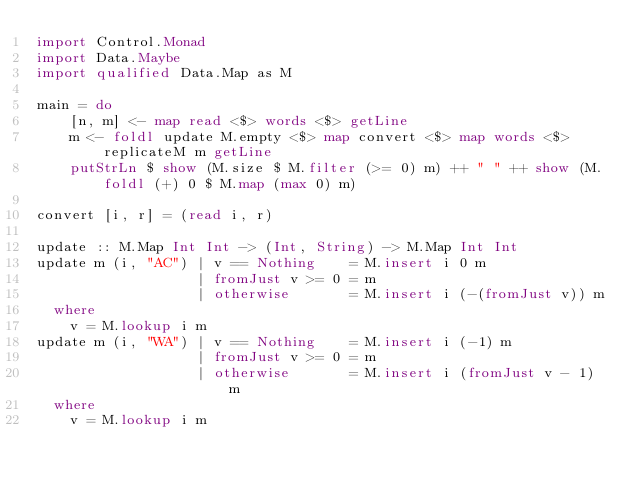Convert code to text. <code><loc_0><loc_0><loc_500><loc_500><_Haskell_>import Control.Monad
import Data.Maybe
import qualified Data.Map as M

main = do
    [n, m] <- map read <$> words <$> getLine
    m <- foldl update M.empty <$> map convert <$> map words <$> replicateM m getLine
    putStrLn $ show (M.size $ M.filter (>= 0) m) ++ " " ++ show (M.foldl (+) 0 $ M.map (max 0) m)

convert [i, r] = (read i, r)

update :: M.Map Int Int -> (Int, String) -> M.Map Int Int
update m (i, "AC") | v == Nothing    = M.insert i 0 m
                   | fromJust v >= 0 = m
                   | otherwise       = M.insert i (-(fromJust v)) m
  where
    v = M.lookup i m
update m (i, "WA") | v == Nothing    = M.insert i (-1) m
                   | fromJust v >= 0 = m
                   | otherwise       = M.insert i (fromJust v - 1) m
  where
    v = M.lookup i m</code> 